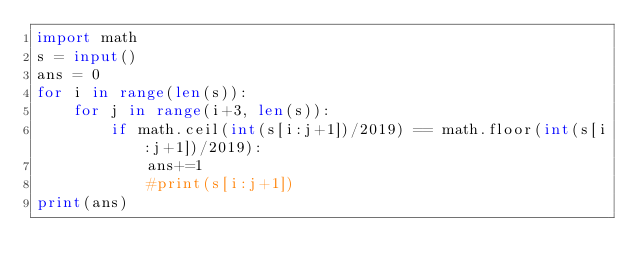Convert code to text. <code><loc_0><loc_0><loc_500><loc_500><_Python_>import math
s = input()
ans = 0
for i in range(len(s)):
	for j in range(i+3, len(s)):
		if math.ceil(int(s[i:j+1])/2019) == math.floor(int(s[i:j+1])/2019): 
			ans+=1
			#print(s[i:j+1])
print(ans)
</code> 